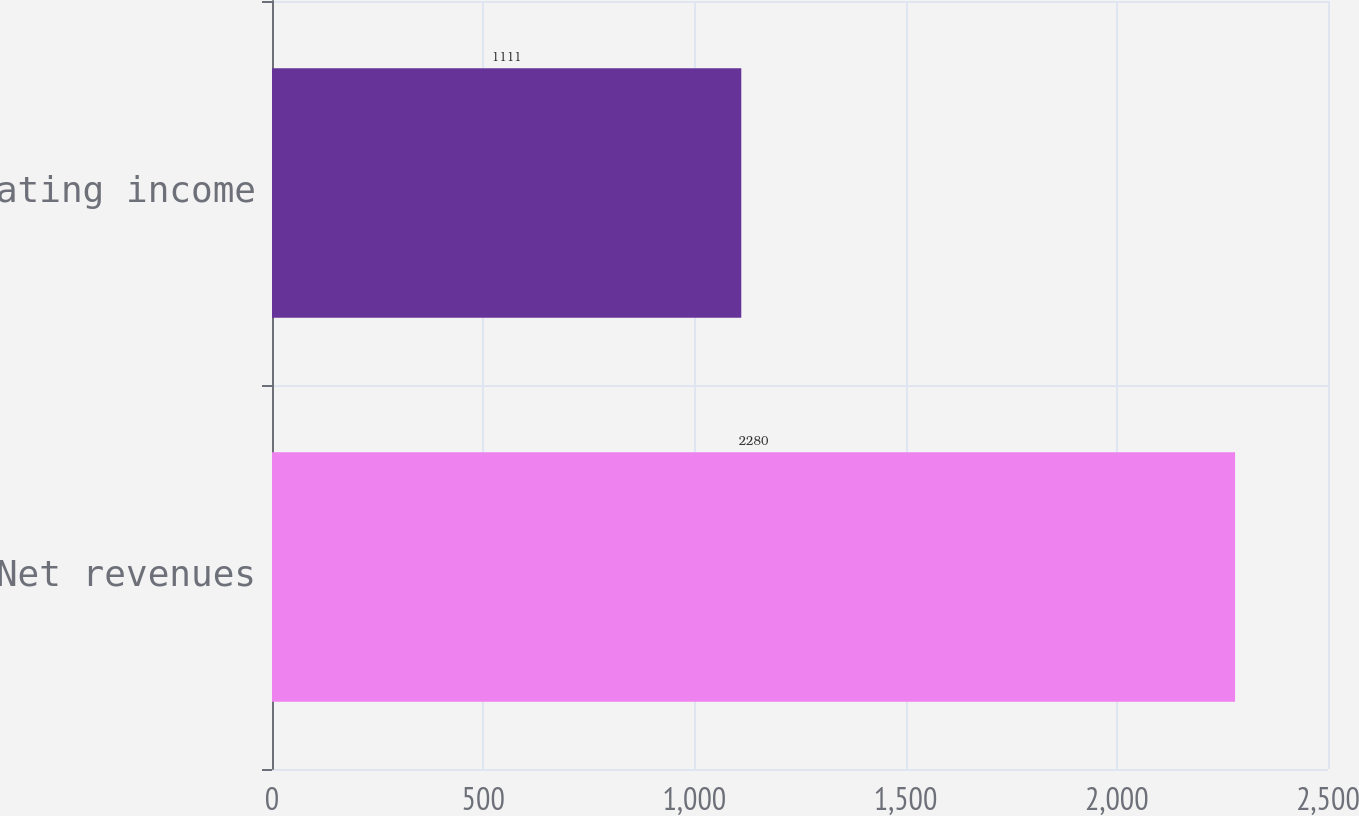<chart> <loc_0><loc_0><loc_500><loc_500><bar_chart><fcel>Net revenues<fcel>Operating income<nl><fcel>2280<fcel>1111<nl></chart> 